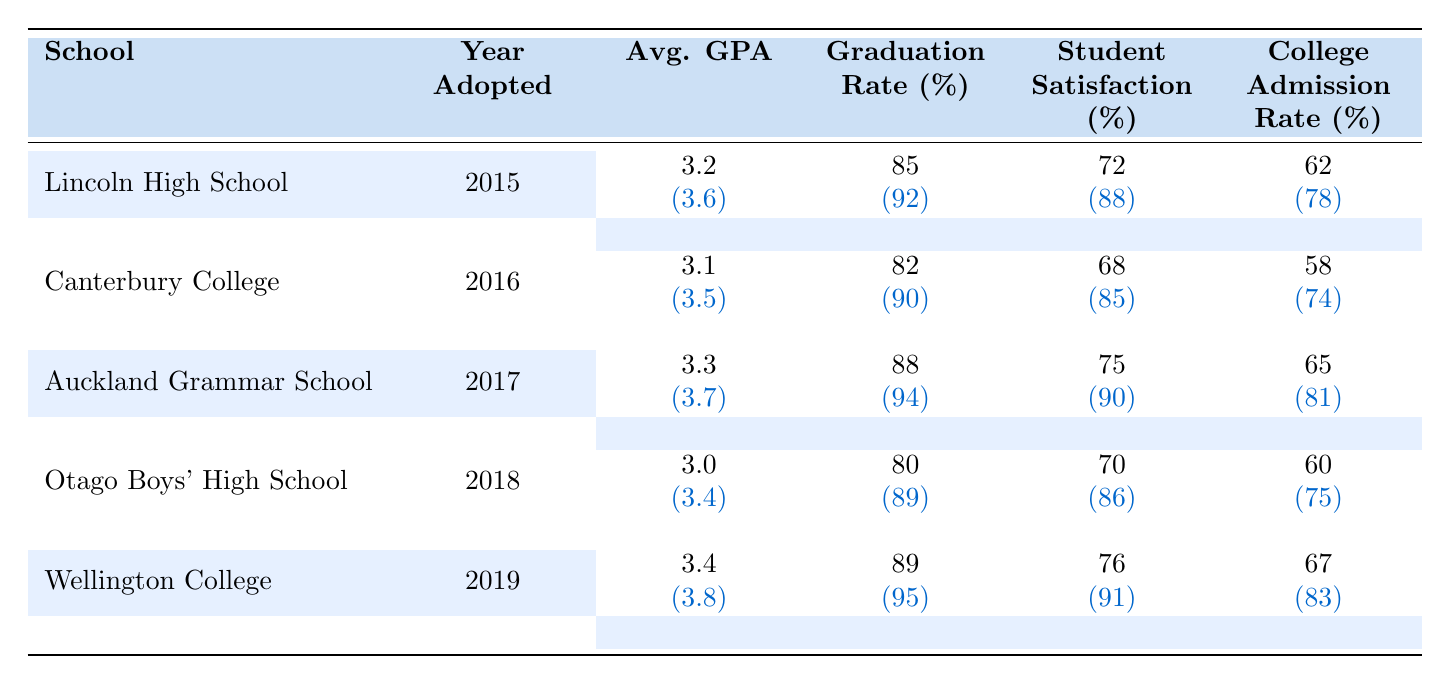What is the average GPA of students at Lincoln High School before adoption? The metrics show that the average GPA before adoption for Lincoln High School is 3.2, as stated in the table.
Answer: 3.2 What was the graduation rate at Wellington College after adopting Renwick's educational philosophies? The graduation rate after adoption for Wellington College is listed as 95% in the table.
Answer: 95% Which school had the highest increase in college admission rate after adoption? The college admission rates before and after adoption for each school were calculated: Lincoln High School (16%), Canterbury College (16%), Auckland Grammar School (16%), Otago Boys' High School (15%), and Wellington College (16%). All of these schools had the same highest increase.
Answer: Lincoln High School, Canterbury College, Auckland Grammar School, Otago Boys' High School, Wellington College Was the student satisfaction at Otago Boys' High School higher before or after adoption? The table shows that the student satisfaction before adoption was 70% and after adoption it increased to 86%, indicating satisfaction was higher after adoption.
Answer: After adoption What is the average graduation rate of all five schools after adopting Renwick's educational philosophies? The graduation rates after adoption for the five schools are: 92%, 90%, 94%, 89%, and 95%. Summing these up gives 90% + 92% + 94% + 89% + 95% = 460%. Dividing by 5 gives the average: 460% / 5 = 92%.
Answer: 92% Did any school record a decrease in teacher retention after adopting Renwick's educational philosophies? Looking at the teacher retention figures for schools before and after adoption shows that all schools improved their retention rates, indicating no school experienced a decrease.
Answer: No What was the student satisfaction rate at Canterbury College before adoption? According to the metrics, the student satisfaction rate at Canterbury College before adoption was 68%.
Answer: 68% Which school showed the smallest increase in average GPA after adoption? The average GPAs before and after adoption were: Lincoln High School (0.4), Canterbury College (0.4), Auckland Grammar School (0.4), Otago Boys' High School (0.4), and Wellington College (0.4). All schools had the same increase.
Answer: All had the same increase What was the college admission rate at Auckland Grammar School before adoption? The college admission rate before adoption for Auckland Grammar School is indicated as 65% in the table.
Answer: 65% If you compare the average GPA before adoption for all schools, which school had the lowest? The average GPAs before adoption are: Lincoln High School (3.2), Canterbury College (3.1), Auckland Grammar School (3.3), Otago Boys' High School (3.0), and Wellington College (3.4). Otago Boys' High School had the lowest at 3.0.
Answer: Otago Boys' High School What was the difference in teacher retention between Auckland Grammar School before and after adoption? The before adoption teacher retention rate for Auckland Grammar School was 80%, and after it increased to 91%. The difference is 91% - 80% = 11%.
Answer: 11% 